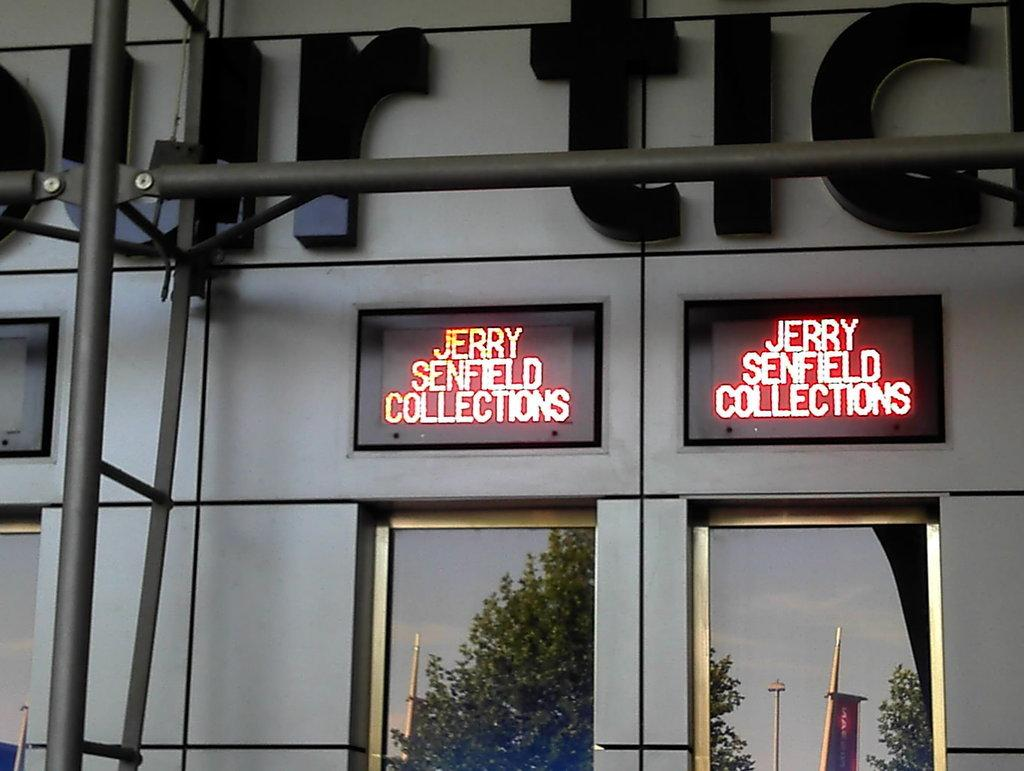What type of objects can be seen in the image that are made of metal? There are metal rods in the image. What type of displays are present in the image? There are digital displays in the image. What type of natural elements can be seen in the image? There are trees in the image. What type of vertical structures are present in the image? There are poles in the image. What type of man-made structure is visible in the image? There is a building in the image. What type of fuel is being used by the beast in the image? There is no beast present in the image, so it is not possible to determine what type of fuel it might be using. 